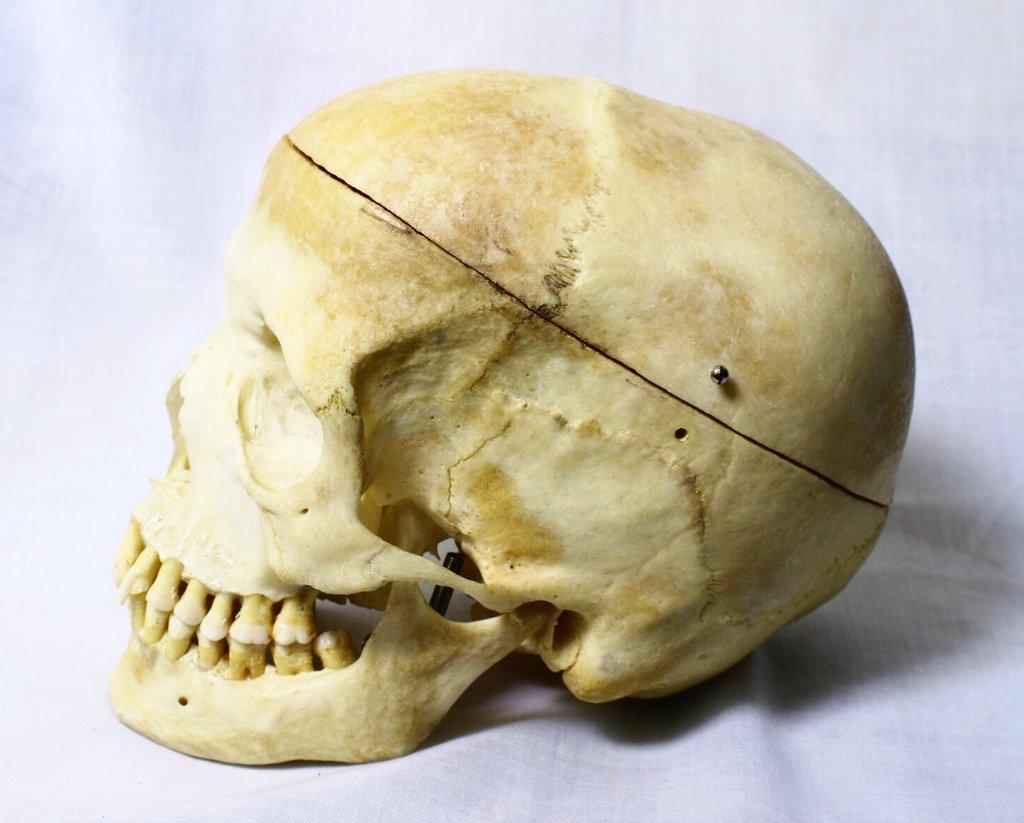Can you describe this image briefly? In this image I can see a human skull which is cream, brown and white in color. I can see the white colored background. 